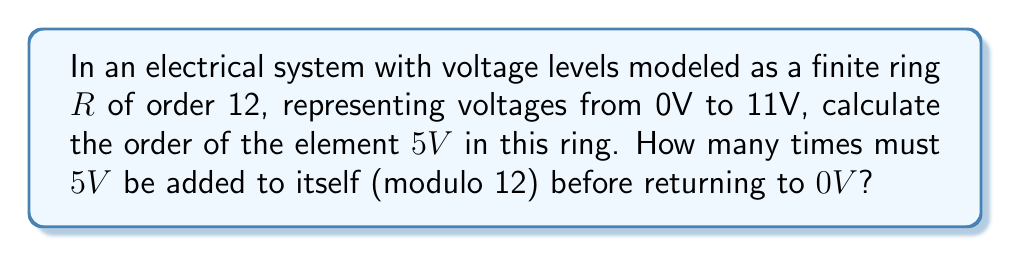Could you help me with this problem? To solve this problem, we need to understand the concept of order in a finite ring and how it applies to our voltage system:

1) In a ring, the order of an element $a$ is the smallest positive integer $n$ such that $na = 0$ (where $0$ is the additive identity of the ring).

2) In our case, we're working in $\mathbb{Z}_{12}$, the ring of integers modulo 12.

3) We need to find how many times we must add $5$ to itself before we get $0$ modulo $12$.

4) Let's calculate the multiples of $5$ modulo $12$:

   $1 \cdot 5 \equiv 5 \pmod{12}$
   $2 \cdot 5 \equiv 10 \pmod{12}$
   $3 \cdot 5 \equiv 3 \pmod{12}$
   $4 \cdot 5 \equiv 8 \pmod{12}$
   $5 \cdot 5 \equiv 1 \pmod{12}$
   $6 \cdot 5 \equiv 6 \pmod{12}$
   $7 \cdot 5 \equiv 11 \pmod{12}$
   $8 \cdot 5 \equiv 4 \pmod{12}$
   $9 \cdot 5 \equiv 9 \pmod{12}$
   $10 \cdot 5 \equiv 2 \pmod{12}$
   $11 \cdot 5 \equiv 7 \pmod{12}$
   $12 \cdot 5 \equiv 0 \pmod{12}$

5) We see that it takes 12 additions of $5$ to return to $0$.

6) Therefore, the order of $5$ in this ring is $12$.

This means that if we continuously add $5V$ in our electrical system, we will cycle through all voltage levels before returning to $0V$ after 12 additions.
Answer: The order of $5V$ in the finite ring $R$ representing voltage levels is $12$. 